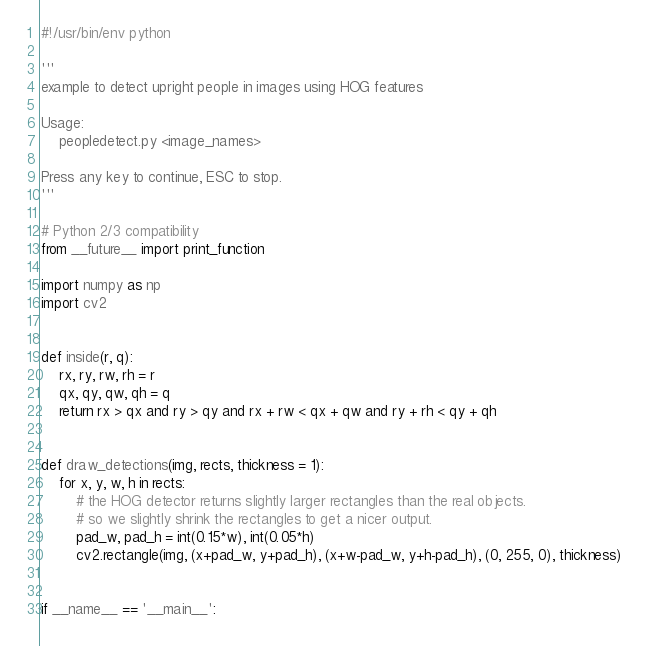<code> <loc_0><loc_0><loc_500><loc_500><_Python_>#!/usr/bin/env python

'''
example to detect upright people in images using HOG features

Usage:
    peopledetect.py <image_names>

Press any key to continue, ESC to stop.
'''

# Python 2/3 compatibility
from __future__ import print_function

import numpy as np
import cv2


def inside(r, q):
    rx, ry, rw, rh = r
    qx, qy, qw, qh = q
    return rx > qx and ry > qy and rx + rw < qx + qw and ry + rh < qy + qh


def draw_detections(img, rects, thickness = 1):
    for x, y, w, h in rects:
        # the HOG detector returns slightly larger rectangles than the real objects.
        # so we slightly shrink the rectangles to get a nicer output.
        pad_w, pad_h = int(0.15*w), int(0.05*h)
        cv2.rectangle(img, (x+pad_w, y+pad_h), (x+w-pad_w, y+h-pad_h), (0, 255, 0), thickness)


if __name__ == '__main__':</code> 